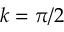<formula> <loc_0><loc_0><loc_500><loc_500>k = \pi / 2</formula> 